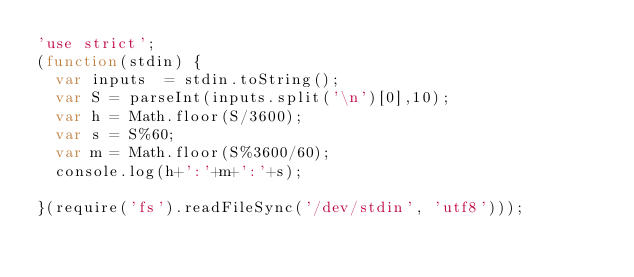<code> <loc_0><loc_0><loc_500><loc_500><_JavaScript_>'use strict';
(function(stdin) {
  var inputs  = stdin.toString();
  var S = parseInt(inputs.split('\n')[0],10);
  var h = Math.floor(S/3600);
  var s = S%60;
  var m = Math.floor(S%3600/60);
  console.log(h+':'+m+':'+s); 
  
}(require('fs').readFileSync('/dev/stdin', 'utf8')));</code> 